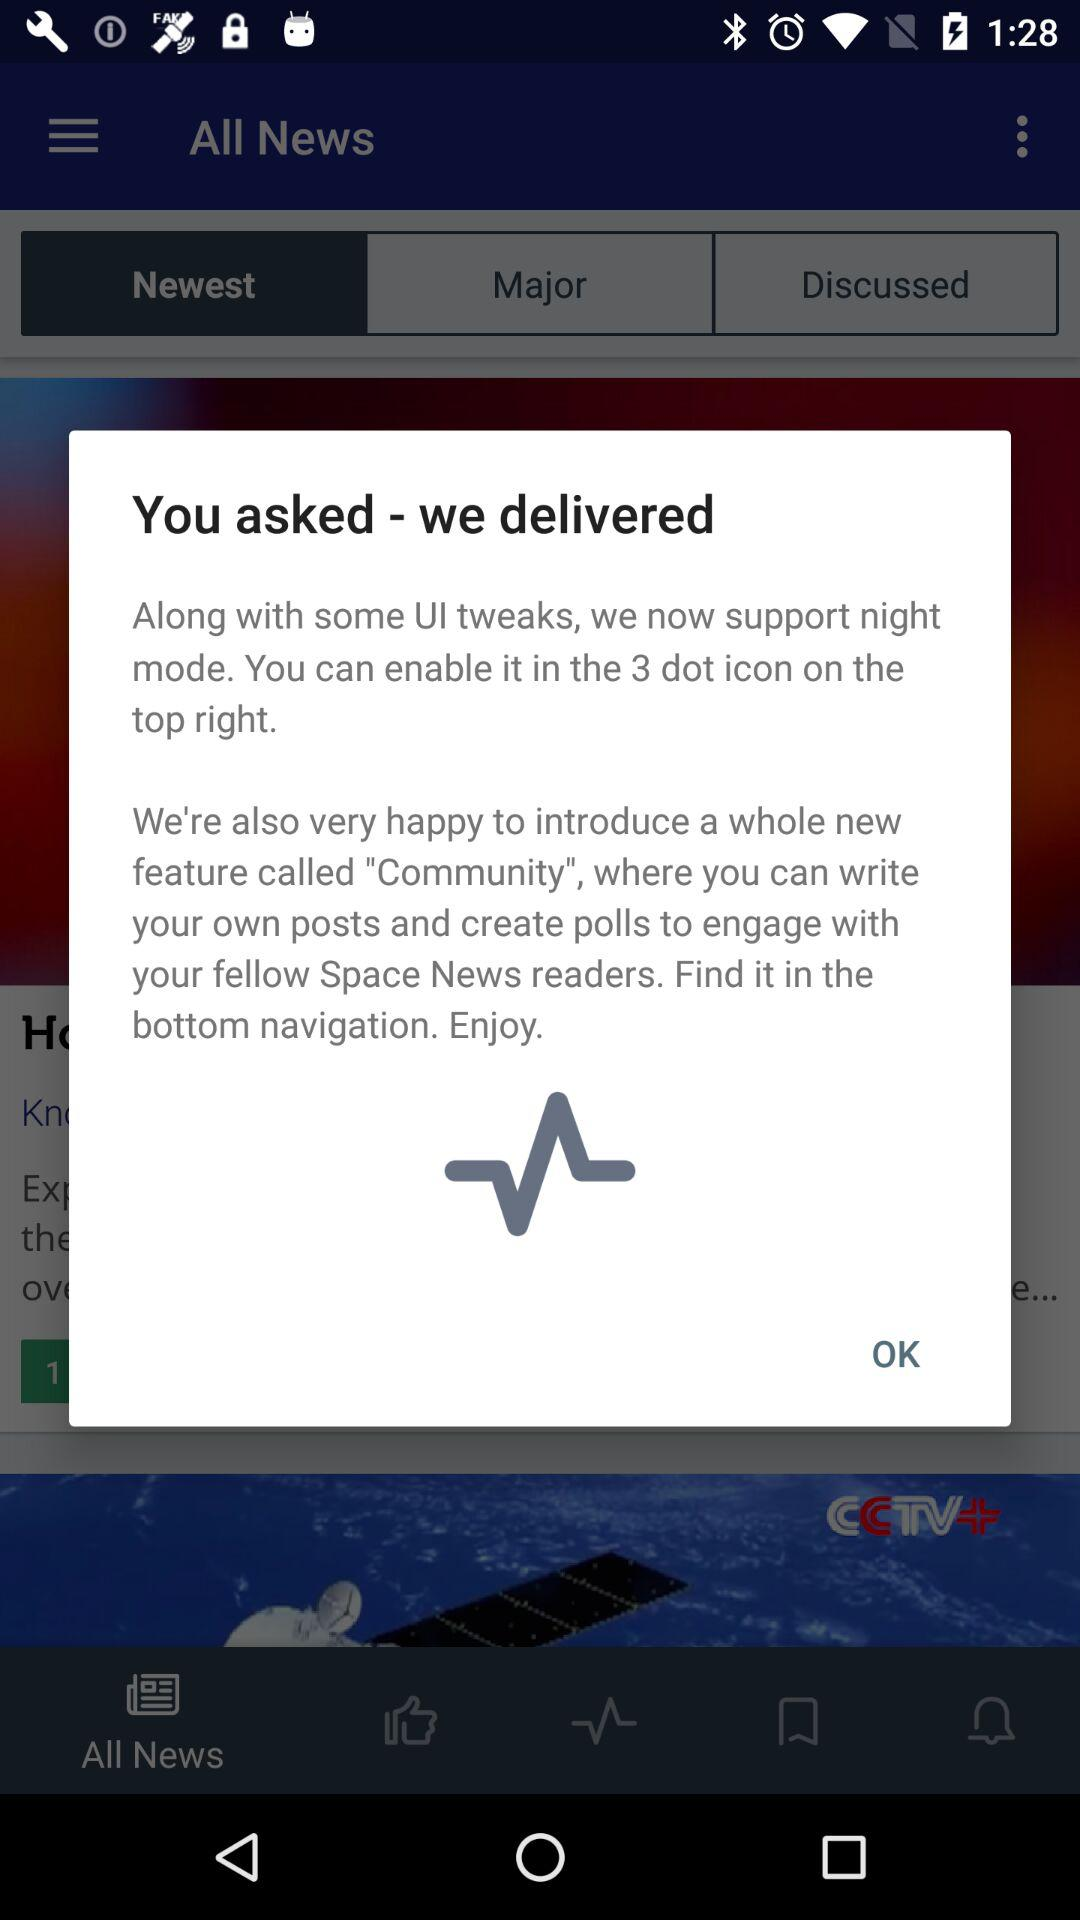Where can you write your own posts and create polls? You can write your own posts and create polls in a feature called "Community". 